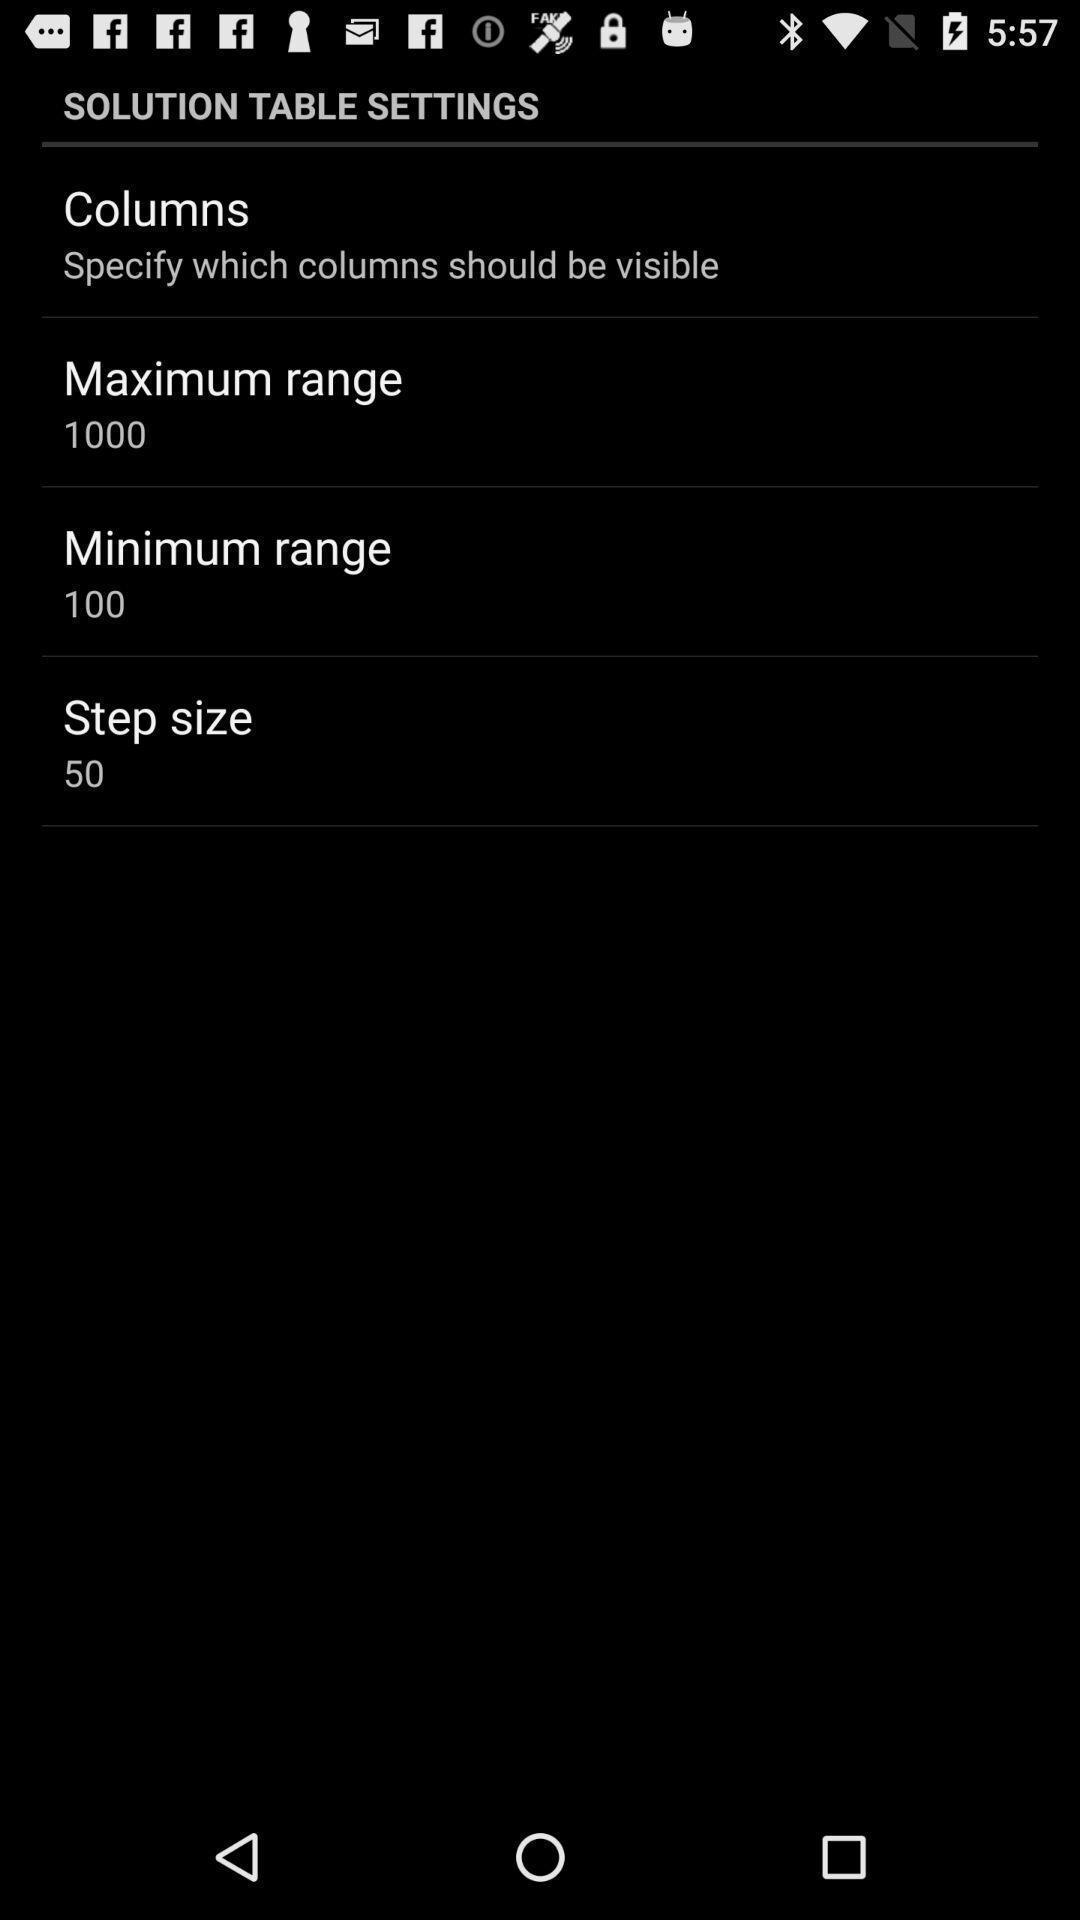What details can you identify in this image? Table settings in the application. 